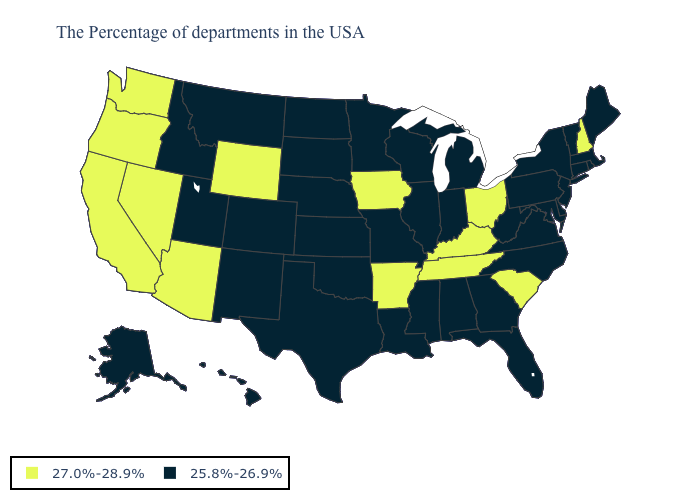Name the states that have a value in the range 27.0%-28.9%?
Be succinct. New Hampshire, South Carolina, Ohio, Kentucky, Tennessee, Arkansas, Iowa, Wyoming, Arizona, Nevada, California, Washington, Oregon. What is the value of Ohio?
Answer briefly. 27.0%-28.9%. Does South Carolina have the highest value in the USA?
Keep it brief. Yes. Name the states that have a value in the range 27.0%-28.9%?
Be succinct. New Hampshire, South Carolina, Ohio, Kentucky, Tennessee, Arkansas, Iowa, Wyoming, Arizona, Nevada, California, Washington, Oregon. Which states have the highest value in the USA?
Answer briefly. New Hampshire, South Carolina, Ohio, Kentucky, Tennessee, Arkansas, Iowa, Wyoming, Arizona, Nevada, California, Washington, Oregon. Among the states that border Illinois , does Kentucky have the highest value?
Short answer required. Yes. Does the map have missing data?
Keep it brief. No. Does Alabama have a higher value than Louisiana?
Write a very short answer. No. What is the lowest value in states that border Montana?
Short answer required. 25.8%-26.9%. Among the states that border Colorado , does Oklahoma have the lowest value?
Write a very short answer. Yes. What is the lowest value in the MidWest?
Short answer required. 25.8%-26.9%. Does Nevada have the highest value in the USA?
Give a very brief answer. Yes. What is the lowest value in the West?
Write a very short answer. 25.8%-26.9%. Does Mississippi have the lowest value in the South?
Write a very short answer. Yes. What is the value of Virginia?
Quick response, please. 25.8%-26.9%. 